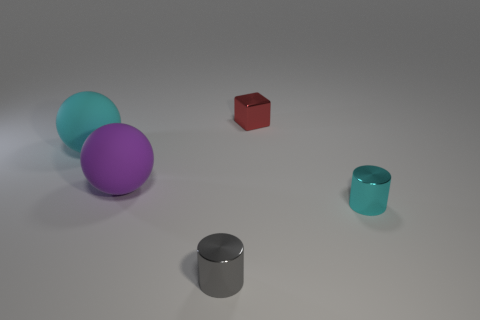The large cyan object has what shape?
Your answer should be compact. Sphere. How many cyan objects have the same shape as the small gray thing?
Keep it short and to the point. 1. How many things are on the right side of the large cyan sphere and to the left of the gray metallic cylinder?
Your response must be concise. 1. The shiny block is what color?
Make the answer very short. Red. Are there any red things that have the same material as the large cyan ball?
Your response must be concise. No. There is a cyan thing that is on the left side of the large purple matte object that is behind the small gray cylinder; is there a large rubber object to the left of it?
Offer a terse response. No. Are there any small things in front of the small red cube?
Provide a short and direct response. Yes. Are there any other cubes that have the same color as the block?
Ensure brevity in your answer.  No. How many tiny things are either red metallic things or cyan matte cylinders?
Your answer should be very brief. 1. Do the large object left of the purple sphere and the gray cylinder have the same material?
Provide a short and direct response. No. 